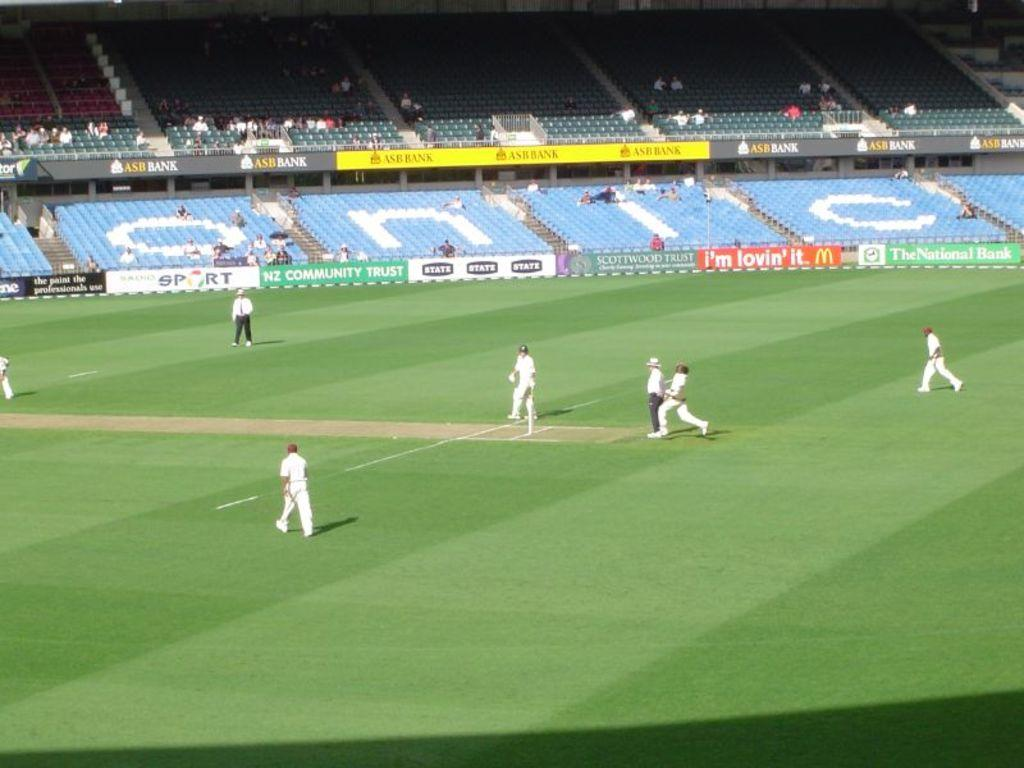<image>
Provide a brief description of the given image. some soccer playes with a Sport logo way behind them 